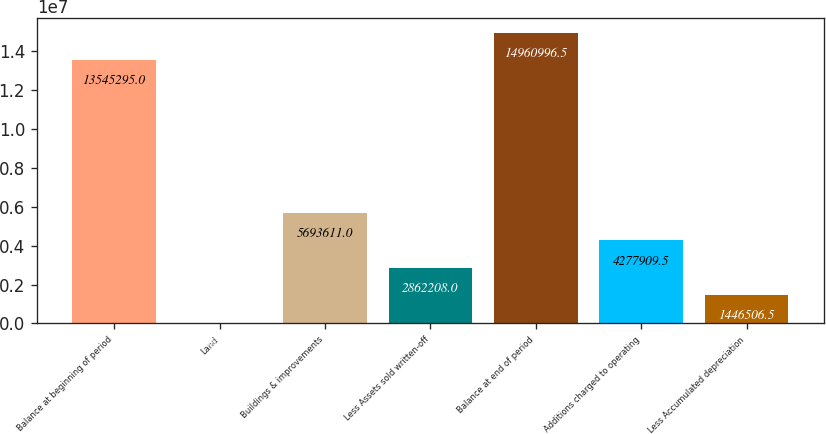<chart> <loc_0><loc_0><loc_500><loc_500><bar_chart><fcel>Balance at beginning of period<fcel>Land<fcel>Buildings & improvements<fcel>Less Assets sold written-off<fcel>Balance at end of period<fcel>Additions charged to operating<fcel>Less Accumulated depreciation<nl><fcel>1.35453e+07<fcel>30805<fcel>5.69361e+06<fcel>2.86221e+06<fcel>1.4961e+07<fcel>4.27791e+06<fcel>1.44651e+06<nl></chart> 